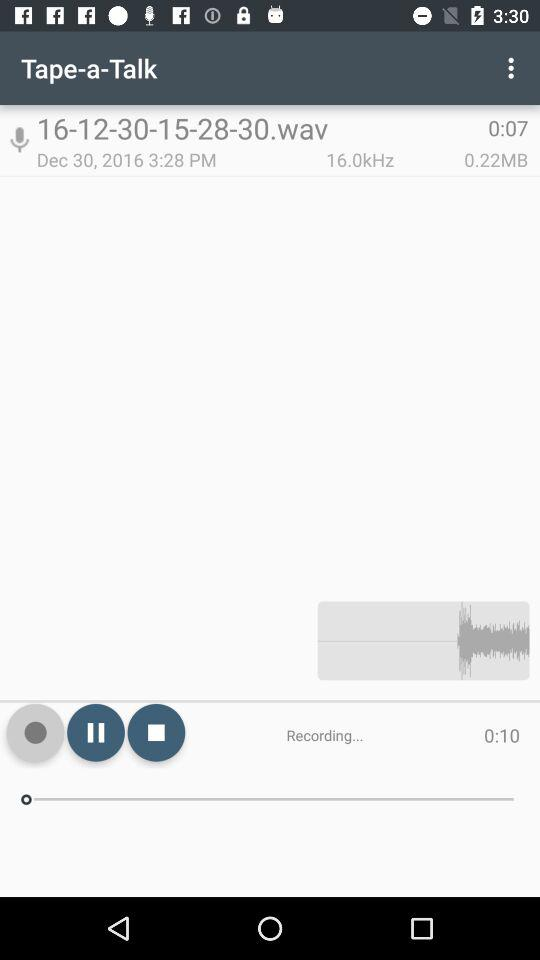How many seconds longer is the recording than the duration?
Answer the question using a single word or phrase. 3 